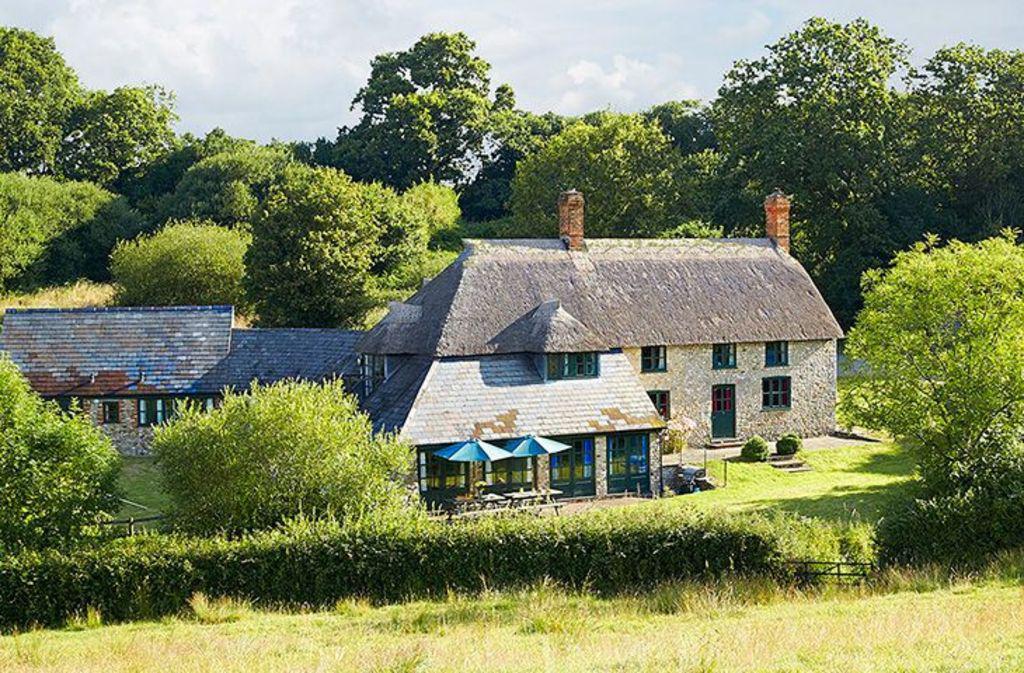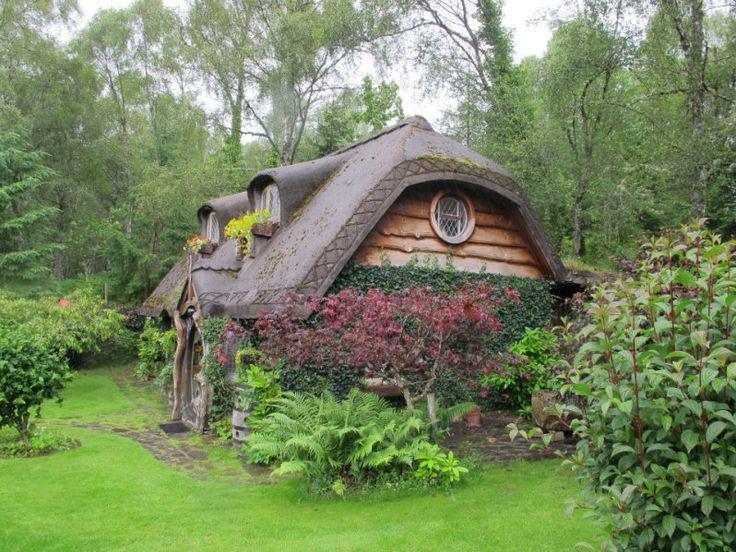The first image is the image on the left, the second image is the image on the right. Given the left and right images, does the statement "The walls of one of the thatched houses is covered with a climbing vine, maybe ivy." hold true? Answer yes or no. Yes. The first image is the image on the left, the second image is the image on the right. Evaluate the accuracy of this statement regarding the images: "There are two chimneys.". Is it true? Answer yes or no. Yes. 